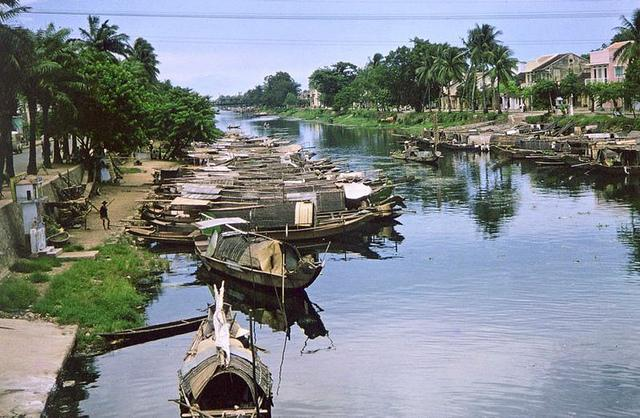What powers those boats? Please explain your reasoning. humans. The boats have no motors so they must be powered manually. 